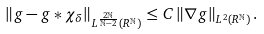Convert formula to latex. <formula><loc_0><loc_0><loc_500><loc_500>\left \| g - g * \chi _ { \delta } \right \| _ { L ^ { \frac { 2 \mathbb { N } } { \mathbb { N } - 2 } } ( R ^ { \mathbb { N } } ) } \leq C \left \| \nabla g \right \| _ { L ^ { 2 } ( R ^ { \mathbb { N } } ) } .</formula> 